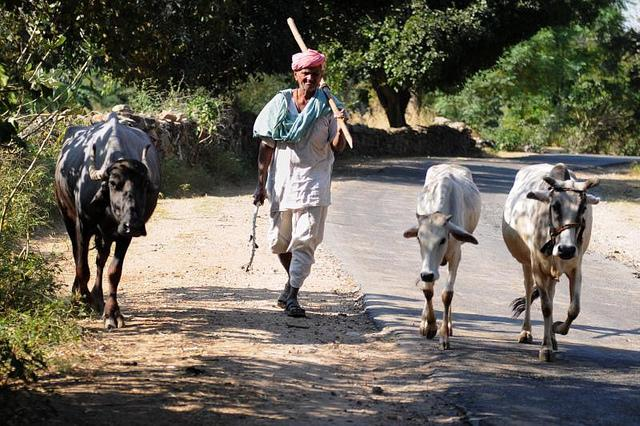What color is the turban worn by the man herding the cows?

Choices:
A) red
B) blue
C) tan
D) white red 